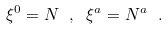<formula> <loc_0><loc_0><loc_500><loc_500>\xi ^ { 0 } = N \ , \ \xi ^ { a } = N ^ { a } \ .</formula> 